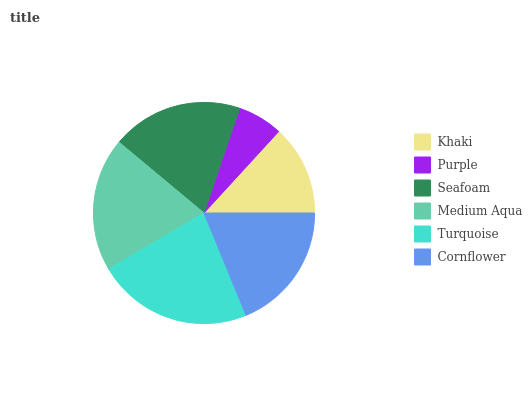Is Purple the minimum?
Answer yes or no. Yes. Is Turquoise the maximum?
Answer yes or no. Yes. Is Seafoam the minimum?
Answer yes or no. No. Is Seafoam the maximum?
Answer yes or no. No. Is Seafoam greater than Purple?
Answer yes or no. Yes. Is Purple less than Seafoam?
Answer yes or no. Yes. Is Purple greater than Seafoam?
Answer yes or no. No. Is Seafoam less than Purple?
Answer yes or no. No. Is Seafoam the high median?
Answer yes or no. Yes. Is Cornflower the low median?
Answer yes or no. Yes. Is Khaki the high median?
Answer yes or no. No. Is Medium Aqua the low median?
Answer yes or no. No. 